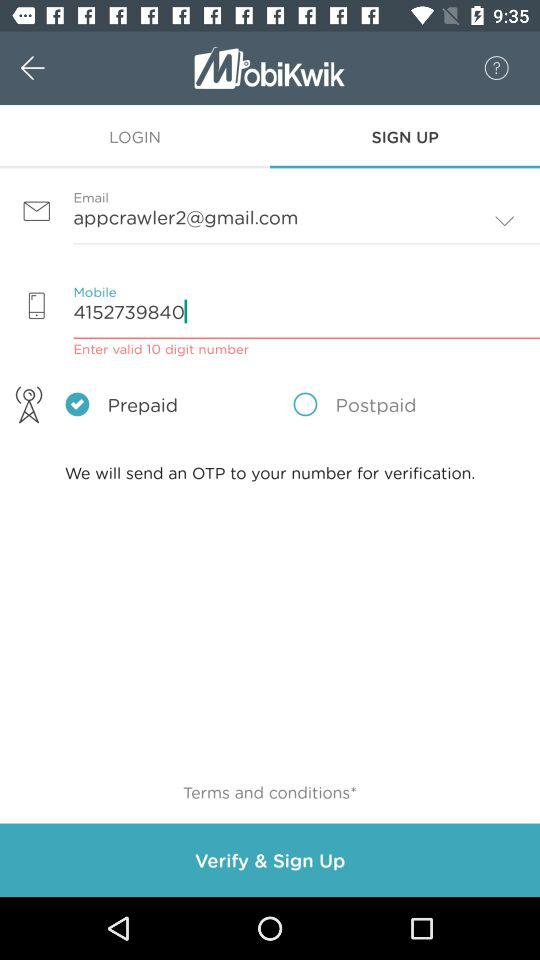What is the email address? The email address is appcrawler2@gmail.com. 